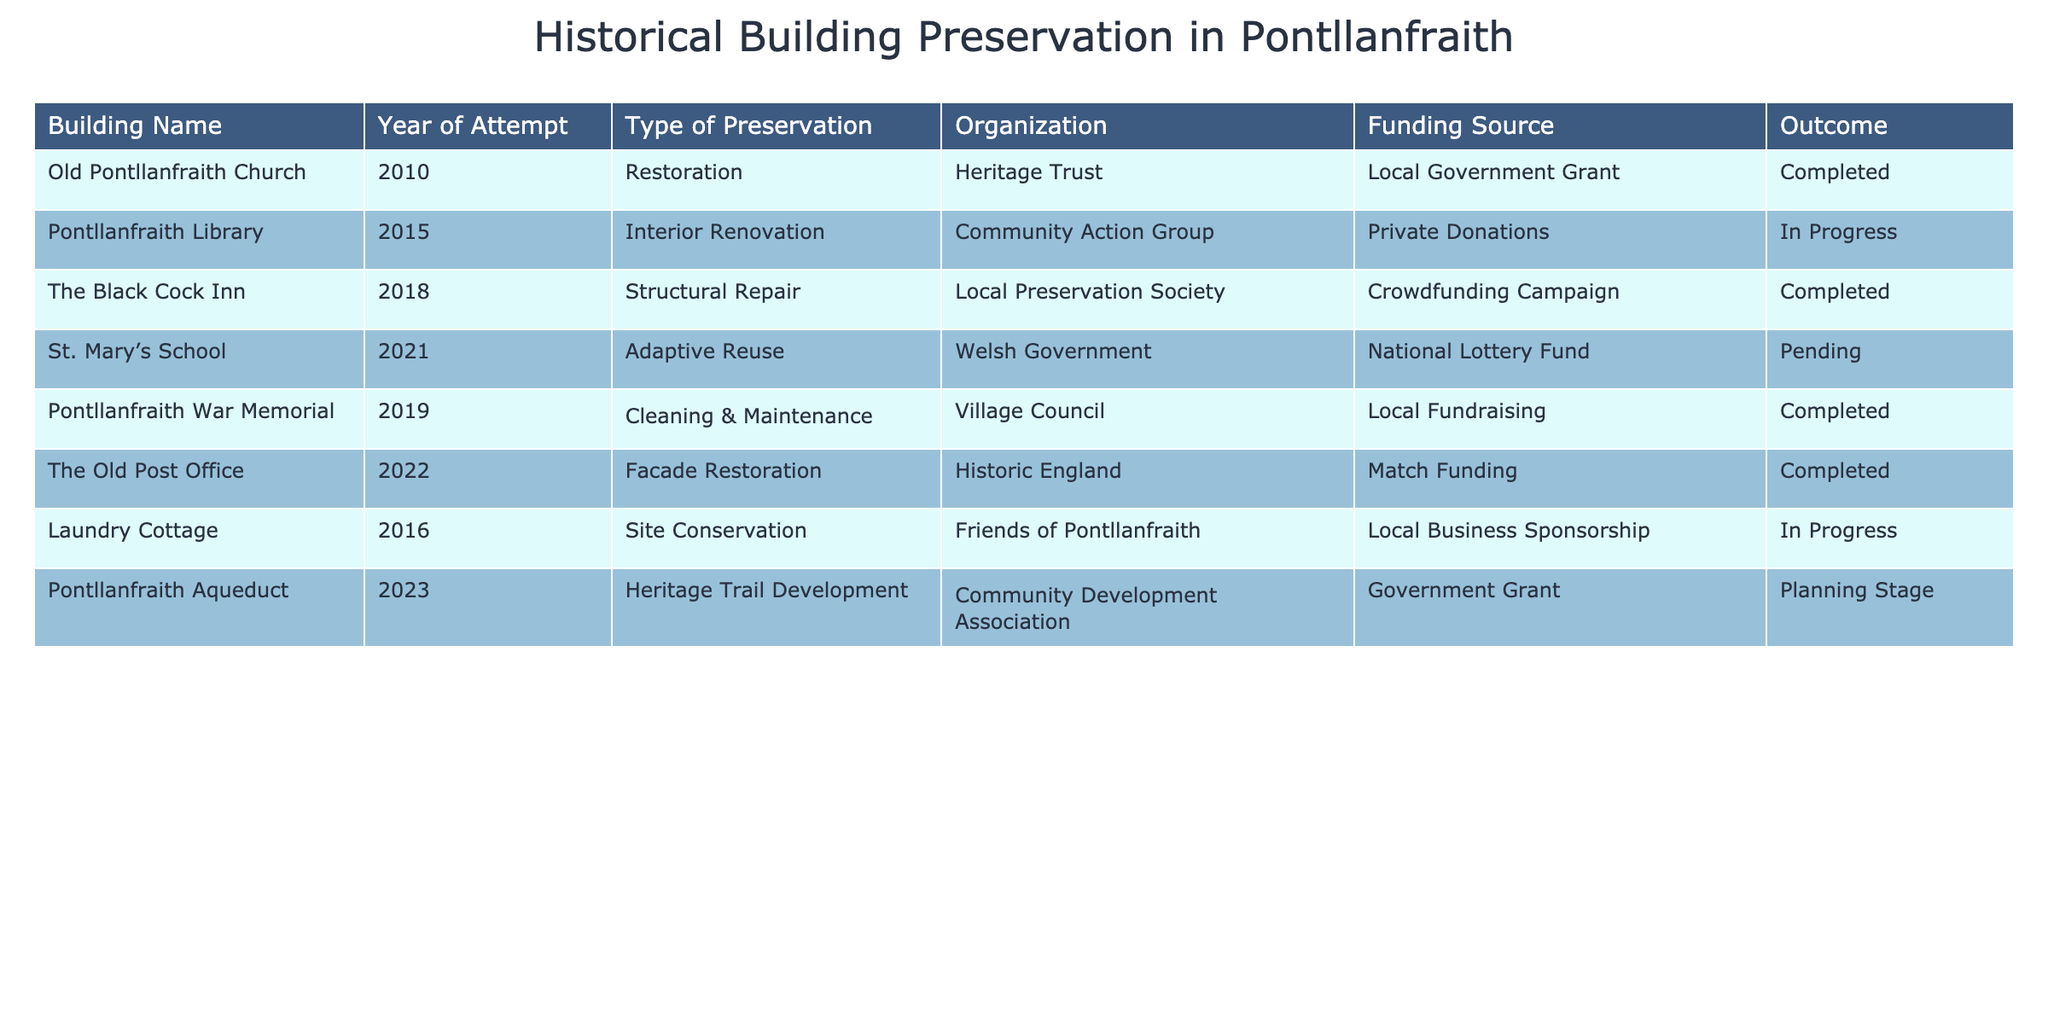What year did the restoration of Old Pontllanfraith Church take place? The table shows that the year of the attempt for the restoration of Old Pontllanfraith Church is 2010.
Answer: 2010 Which building is currently in progress of preservation? Looking at the 'Outcome' column, both Pontllanfraith Library and Laundry Cottage are listed as 'In Progress', indicating that these two buildings are currently undergoing preservation efforts.
Answer: Pontllanfraith Library and Laundry Cottage What type of preservation was used for The Black Cock Inn? The table indicates that The Black Cock Inn underwent 'Structural Repair' as its type of preservation.
Answer: Structural Repair Which organization is associated with the adaptive reuse of St. Mary’s School? The table reveals that the organization involved in the adaptive reuse of St. Mary’s School is the Welsh Government.
Answer: Welsh Government How many buildings have completed preservation attempts? By inspecting the 'Outcome' column, we can count the number of entries that say 'Completed'. There are four such buildings: Old Pontllanfraith Church, The Black Cock Inn, Pontllanfraith War Memorial, and The Old Post Office.
Answer: 4 What is the funding source for the preservation of Laundry Cottage? The table specifies that the funding source for Laundry Cottage is 'Local Business Sponsorship'.
Answer: Local Business Sponsorship Is there any building for which the preservation attempt is currently pending? The table shows that St. Mary’s School is marked as 'Pending' for its preservation outcome, confirming that there is indeed a building in that state.
Answer: Yes Which year had the maximum number of preservation attempts listed? From the years mentioned in the 'Year of Attempt' column, we see multiple attempts in different years. However, 2015 (Pontllanfraith Library) and 2016 (Laundry Cottage) both had attempts, but other years had only one each. No other year has more than one entry. Hence, no year had more than one attempt.
Answer: 2016 and 2015 What is the total number of preservation attempts identified in the table? By counting all distinct rows in the table, we find there are eight separate preservation attempts listed.
Answer: 8 In which year was the cleaning and maintenance of Pontllanfraith War Memorial completed? The table indicates that the cleaning and maintenance of Pontllanfraith War Memorial was completed in 2019.
Answer: 2019 What type of preservation was conducted for the Pontllanfraith Aqueduct and what is its current status? The table states that the Pontllanfraith Aqueduct is involved in 'Heritage Trail Development', and the current status is 'Planning Stage'.
Answer: Heritage Trail Development, Planning Stage Which two organizations used public funding sources for preservation attempts? By reviewing the 'Funding Source' column, it is observed that both the 'Welsh Government' and 'Local Government Grant' are public funding sources, associated with St. Mary’s School and Old Pontllanfraith Church respectively.
Answer: Welsh Government and Local Government Grant 